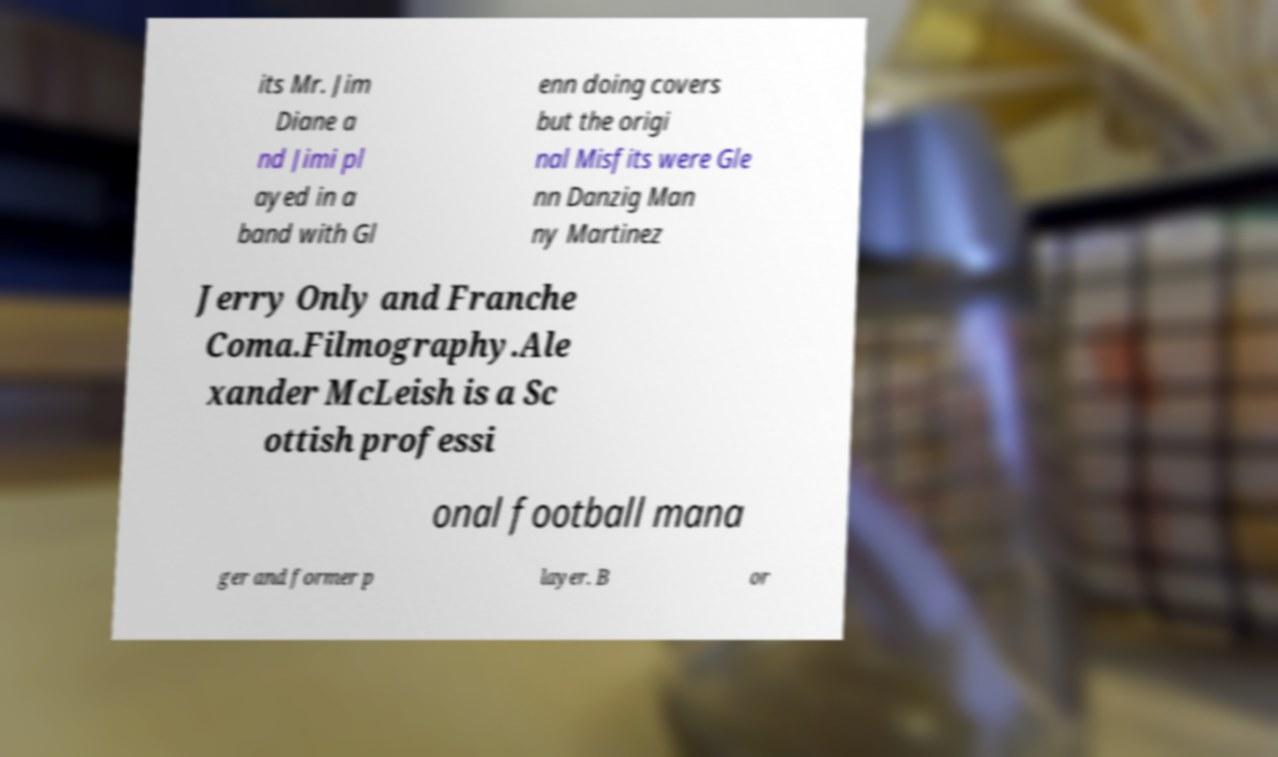For documentation purposes, I need the text within this image transcribed. Could you provide that? its Mr. Jim Diane a nd Jimi pl ayed in a band with Gl enn doing covers but the origi nal Misfits were Gle nn Danzig Man ny Martinez Jerry Only and Franche Coma.Filmography.Ale xander McLeish is a Sc ottish professi onal football mana ger and former p layer. B or 